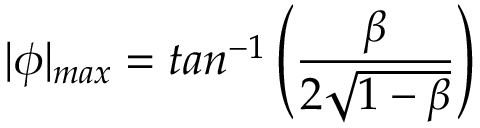<formula> <loc_0><loc_0><loc_500><loc_500>| \phi | _ { \max } = t a n ^ { - 1 } \left ( \frac { \beta } { 2 \sqrt { 1 - \beta } } \right )</formula> 